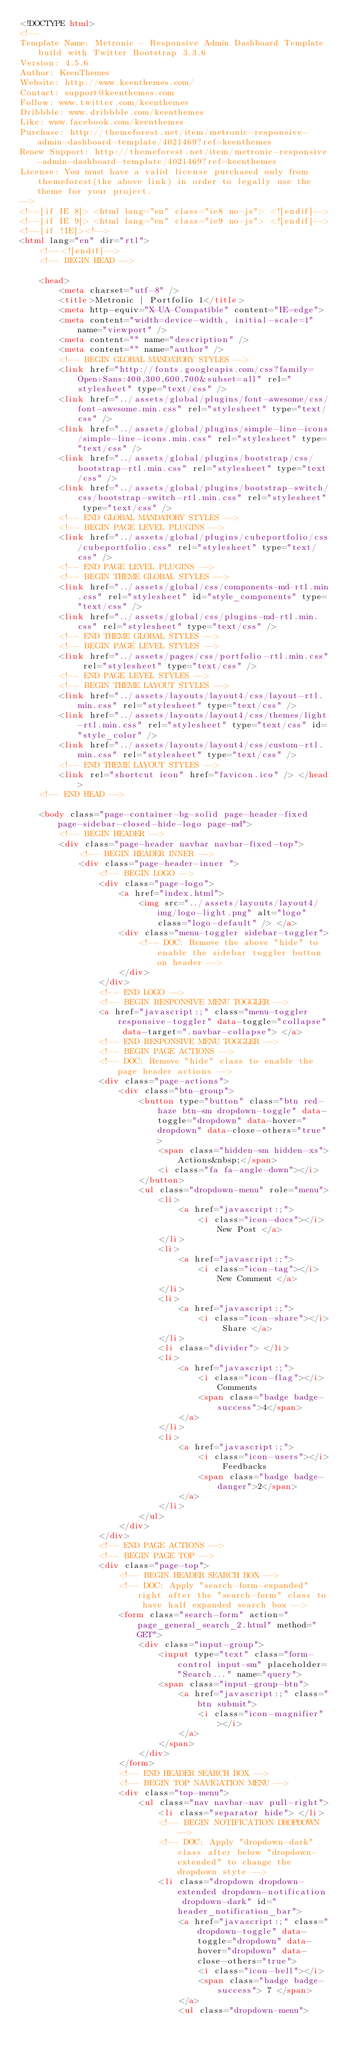Convert code to text. <code><loc_0><loc_0><loc_500><loc_500><_HTML_><!DOCTYPE html>
<!-- 
Template Name: Metronic - Responsive Admin Dashboard Template build with Twitter Bootstrap 3.3.6
Version: 4.5.6
Author: KeenThemes
Website: http://www.keenthemes.com/
Contact: support@keenthemes.com
Follow: www.twitter.com/keenthemes
Dribbble: www.dribbble.com/keenthemes
Like: www.facebook.com/keenthemes
Purchase: http://themeforest.net/item/metronic-responsive-admin-dashboard-template/4021469?ref=keenthemes
Renew Support: http://themeforest.net/item/metronic-responsive-admin-dashboard-template/4021469?ref=keenthemes
License: You must have a valid license purchased only from themeforest(the above link) in order to legally use the theme for your project.
-->
<!--[if IE 8]> <html lang="en" class="ie8 no-js"> <![endif]-->
<!--[if IE 9]> <html lang="en" class="ie9 no-js"> <![endif]-->
<!--[if !IE]><!-->
<html lang="en" dir="rtl">
    <!--<![endif]-->
    <!-- BEGIN HEAD -->

    <head>
        <meta charset="utf-8" />
        <title>Metronic | Portfolio 1</title>
        <meta http-equiv="X-UA-Compatible" content="IE=edge">
        <meta content="width=device-width, initial-scale=1" name="viewport" />
        <meta content="" name="description" />
        <meta content="" name="author" />
        <!-- BEGIN GLOBAL MANDATORY STYLES -->
        <link href="http://fonts.googleapis.com/css?family=Open+Sans:400,300,600,700&subset=all" rel="stylesheet" type="text/css" />
        <link href="../assets/global/plugins/font-awesome/css/font-awesome.min.css" rel="stylesheet" type="text/css" />
        <link href="../assets/global/plugins/simple-line-icons/simple-line-icons.min.css" rel="stylesheet" type="text/css" />
        <link href="../assets/global/plugins/bootstrap/css/bootstrap-rtl.min.css" rel="stylesheet" type="text/css" />
        <link href="../assets/global/plugins/bootstrap-switch/css/bootstrap-switch-rtl.min.css" rel="stylesheet" type="text/css" />
        <!-- END GLOBAL MANDATORY STYLES -->
        <!-- BEGIN PAGE LEVEL PLUGINS -->
        <link href="../assets/global/plugins/cubeportfolio/css/cubeportfolio.css" rel="stylesheet" type="text/css" />
        <!-- END PAGE LEVEL PLUGINS -->
        <!-- BEGIN THEME GLOBAL STYLES -->
        <link href="../assets/global/css/components-md-rtl.min.css" rel="stylesheet" id="style_components" type="text/css" />
        <link href="../assets/global/css/plugins-md-rtl.min.css" rel="stylesheet" type="text/css" />
        <!-- END THEME GLOBAL STYLES -->
        <!-- BEGIN PAGE LEVEL STYLES -->
        <link href="../assets/pages/css/portfolio-rtl.min.css" rel="stylesheet" type="text/css" />
        <!-- END PAGE LEVEL STYLES -->
        <!-- BEGIN THEME LAYOUT STYLES -->
        <link href="../assets/layouts/layout4/css/layout-rtl.min.css" rel="stylesheet" type="text/css" />
        <link href="../assets/layouts/layout4/css/themes/light-rtl.min.css" rel="stylesheet" type="text/css" id="style_color" />
        <link href="../assets/layouts/layout4/css/custom-rtl.min.css" rel="stylesheet" type="text/css" />
        <!-- END THEME LAYOUT STYLES -->
        <link rel="shortcut icon" href="favicon.ico" /> </head>
    <!-- END HEAD -->

    <body class="page-container-bg-solid page-header-fixed page-sidebar-closed-hide-logo page-md">
        <!-- BEGIN HEADER -->
        <div class="page-header navbar navbar-fixed-top">
            <!-- BEGIN HEADER INNER -->
            <div class="page-header-inner ">
                <!-- BEGIN LOGO -->
                <div class="page-logo">
                    <a href="index.html">
                        <img src="../assets/layouts/layout4/img/logo-light.png" alt="logo" class="logo-default" /> </a>
                    <div class="menu-toggler sidebar-toggler">
                        <!-- DOC: Remove the above "hide" to enable the sidebar toggler button on header -->
                    </div>
                </div>
                <!-- END LOGO -->
                <!-- BEGIN RESPONSIVE MENU TOGGLER -->
                <a href="javascript:;" class="menu-toggler responsive-toggler" data-toggle="collapse" data-target=".navbar-collapse"> </a>
                <!-- END RESPONSIVE MENU TOGGLER -->
                <!-- BEGIN PAGE ACTIONS -->
                <!-- DOC: Remove "hide" class to enable the page header actions -->
                <div class="page-actions">
                    <div class="btn-group">
                        <button type="button" class="btn red-haze btn-sm dropdown-toggle" data-toggle="dropdown" data-hover="dropdown" data-close-others="true">
                            <span class="hidden-sm hidden-xs">Actions&nbsp;</span>
                            <i class="fa fa-angle-down"></i>
                        </button>
                        <ul class="dropdown-menu" role="menu">
                            <li>
                                <a href="javascript:;">
                                    <i class="icon-docs"></i> New Post </a>
                            </li>
                            <li>
                                <a href="javascript:;">
                                    <i class="icon-tag"></i> New Comment </a>
                            </li>
                            <li>
                                <a href="javascript:;">
                                    <i class="icon-share"></i> Share </a>
                            </li>
                            <li class="divider"> </li>
                            <li>
                                <a href="javascript:;">
                                    <i class="icon-flag"></i> Comments
                                    <span class="badge badge-success">4</span>
                                </a>
                            </li>
                            <li>
                                <a href="javascript:;">
                                    <i class="icon-users"></i> Feedbacks
                                    <span class="badge badge-danger">2</span>
                                </a>
                            </li>
                        </ul>
                    </div>
                </div>
                <!-- END PAGE ACTIONS -->
                <!-- BEGIN PAGE TOP -->
                <div class="page-top">
                    <!-- BEGIN HEADER SEARCH BOX -->
                    <!-- DOC: Apply "search-form-expanded" right after the "search-form" class to have half expanded search box -->
                    <form class="search-form" action="page_general_search_2.html" method="GET">
                        <div class="input-group">
                            <input type="text" class="form-control input-sm" placeholder="Search..." name="query">
                            <span class="input-group-btn">
                                <a href="javascript:;" class="btn submit">
                                    <i class="icon-magnifier"></i>
                                </a>
                            </span>
                        </div>
                    </form>
                    <!-- END HEADER SEARCH BOX -->
                    <!-- BEGIN TOP NAVIGATION MENU -->
                    <div class="top-menu">
                        <ul class="nav navbar-nav pull-right">
                            <li class="separator hide"> </li>
                            <!-- BEGIN NOTIFICATION DROPDOWN -->
                            <!-- DOC: Apply "dropdown-dark" class after below "dropdown-extended" to change the dropdown styte -->
                            <li class="dropdown dropdown-extended dropdown-notification dropdown-dark" id="header_notification_bar">
                                <a href="javascript:;" class="dropdown-toggle" data-toggle="dropdown" data-hover="dropdown" data-close-others="true">
                                    <i class="icon-bell"></i>
                                    <span class="badge badge-success"> 7 </span>
                                </a>
                                <ul class="dropdown-menu"></code> 